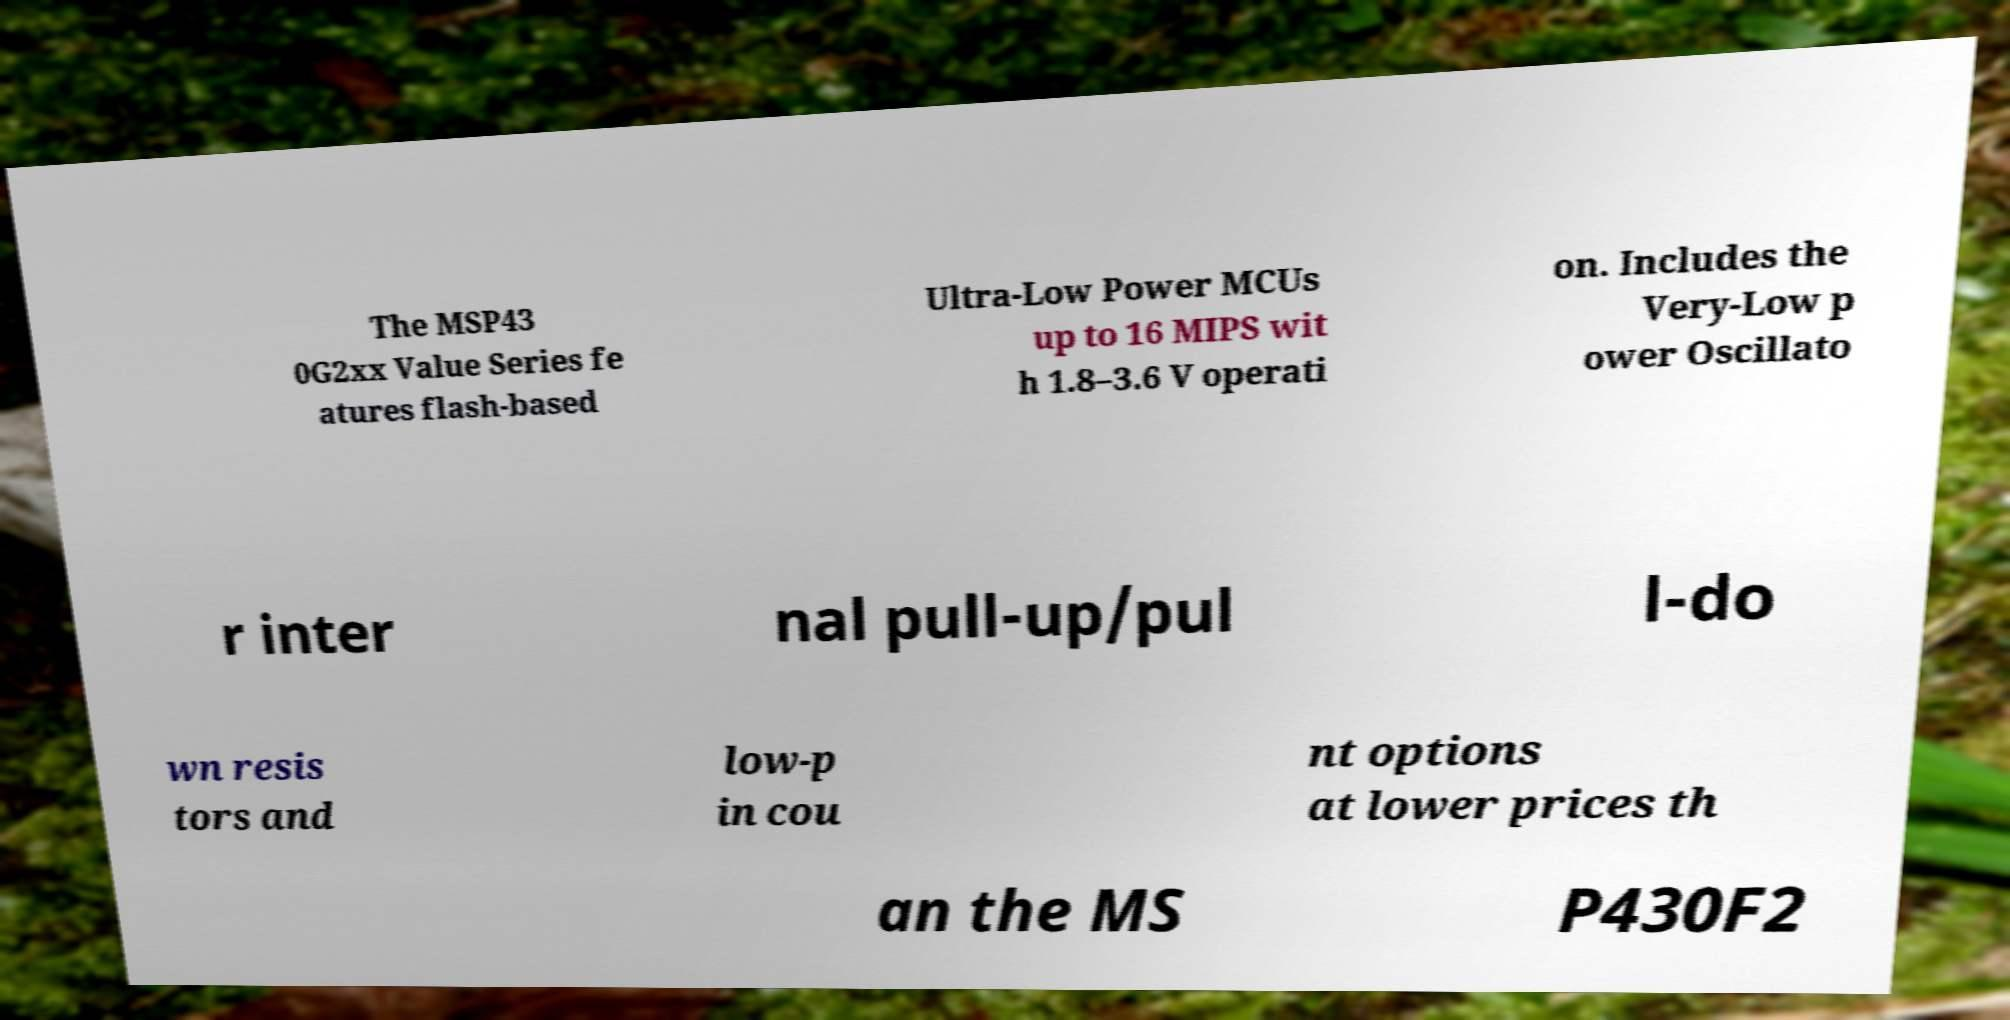I need the written content from this picture converted into text. Can you do that? The MSP43 0G2xx Value Series fe atures flash-based Ultra-Low Power MCUs up to 16 MIPS wit h 1.8–3.6 V operati on. Includes the Very-Low p ower Oscillato r inter nal pull-up/pul l-do wn resis tors and low-p in cou nt options at lower prices th an the MS P430F2 